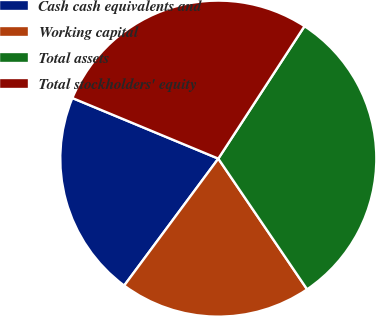Convert chart to OTSL. <chart><loc_0><loc_0><loc_500><loc_500><pie_chart><fcel>Cash cash equivalents and<fcel>Working capital<fcel>Total assets<fcel>Total stockholders' equity<nl><fcel>21.11%<fcel>19.65%<fcel>31.32%<fcel>27.92%<nl></chart> 